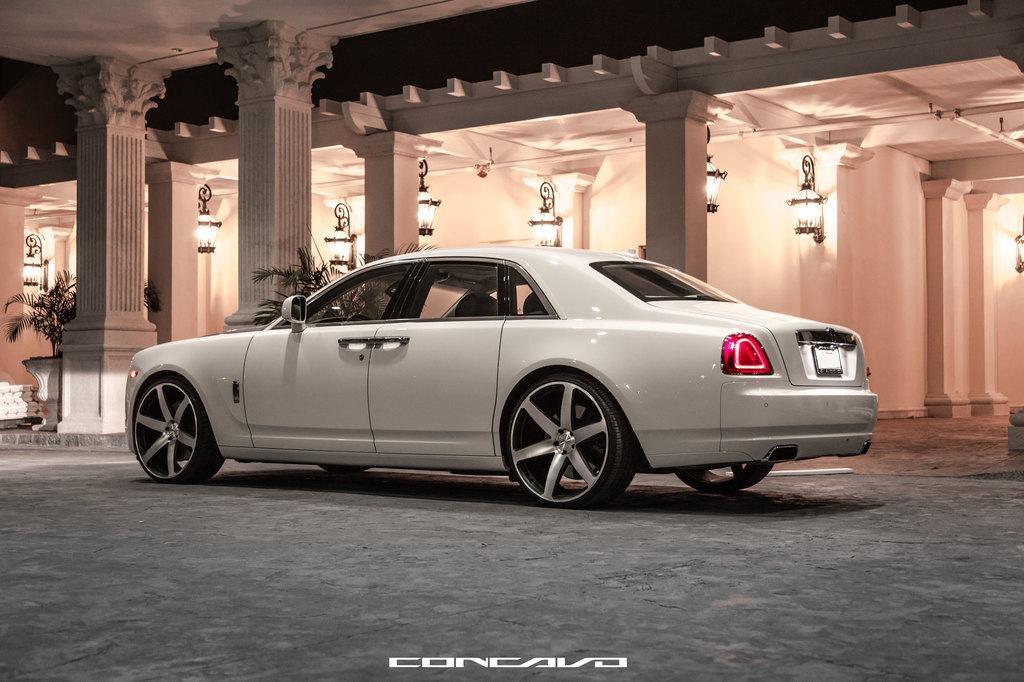Describe this image in one or two sentences. In this image we can see a car on the road. In the background of the image there is building. There are pillars. There are lights. 